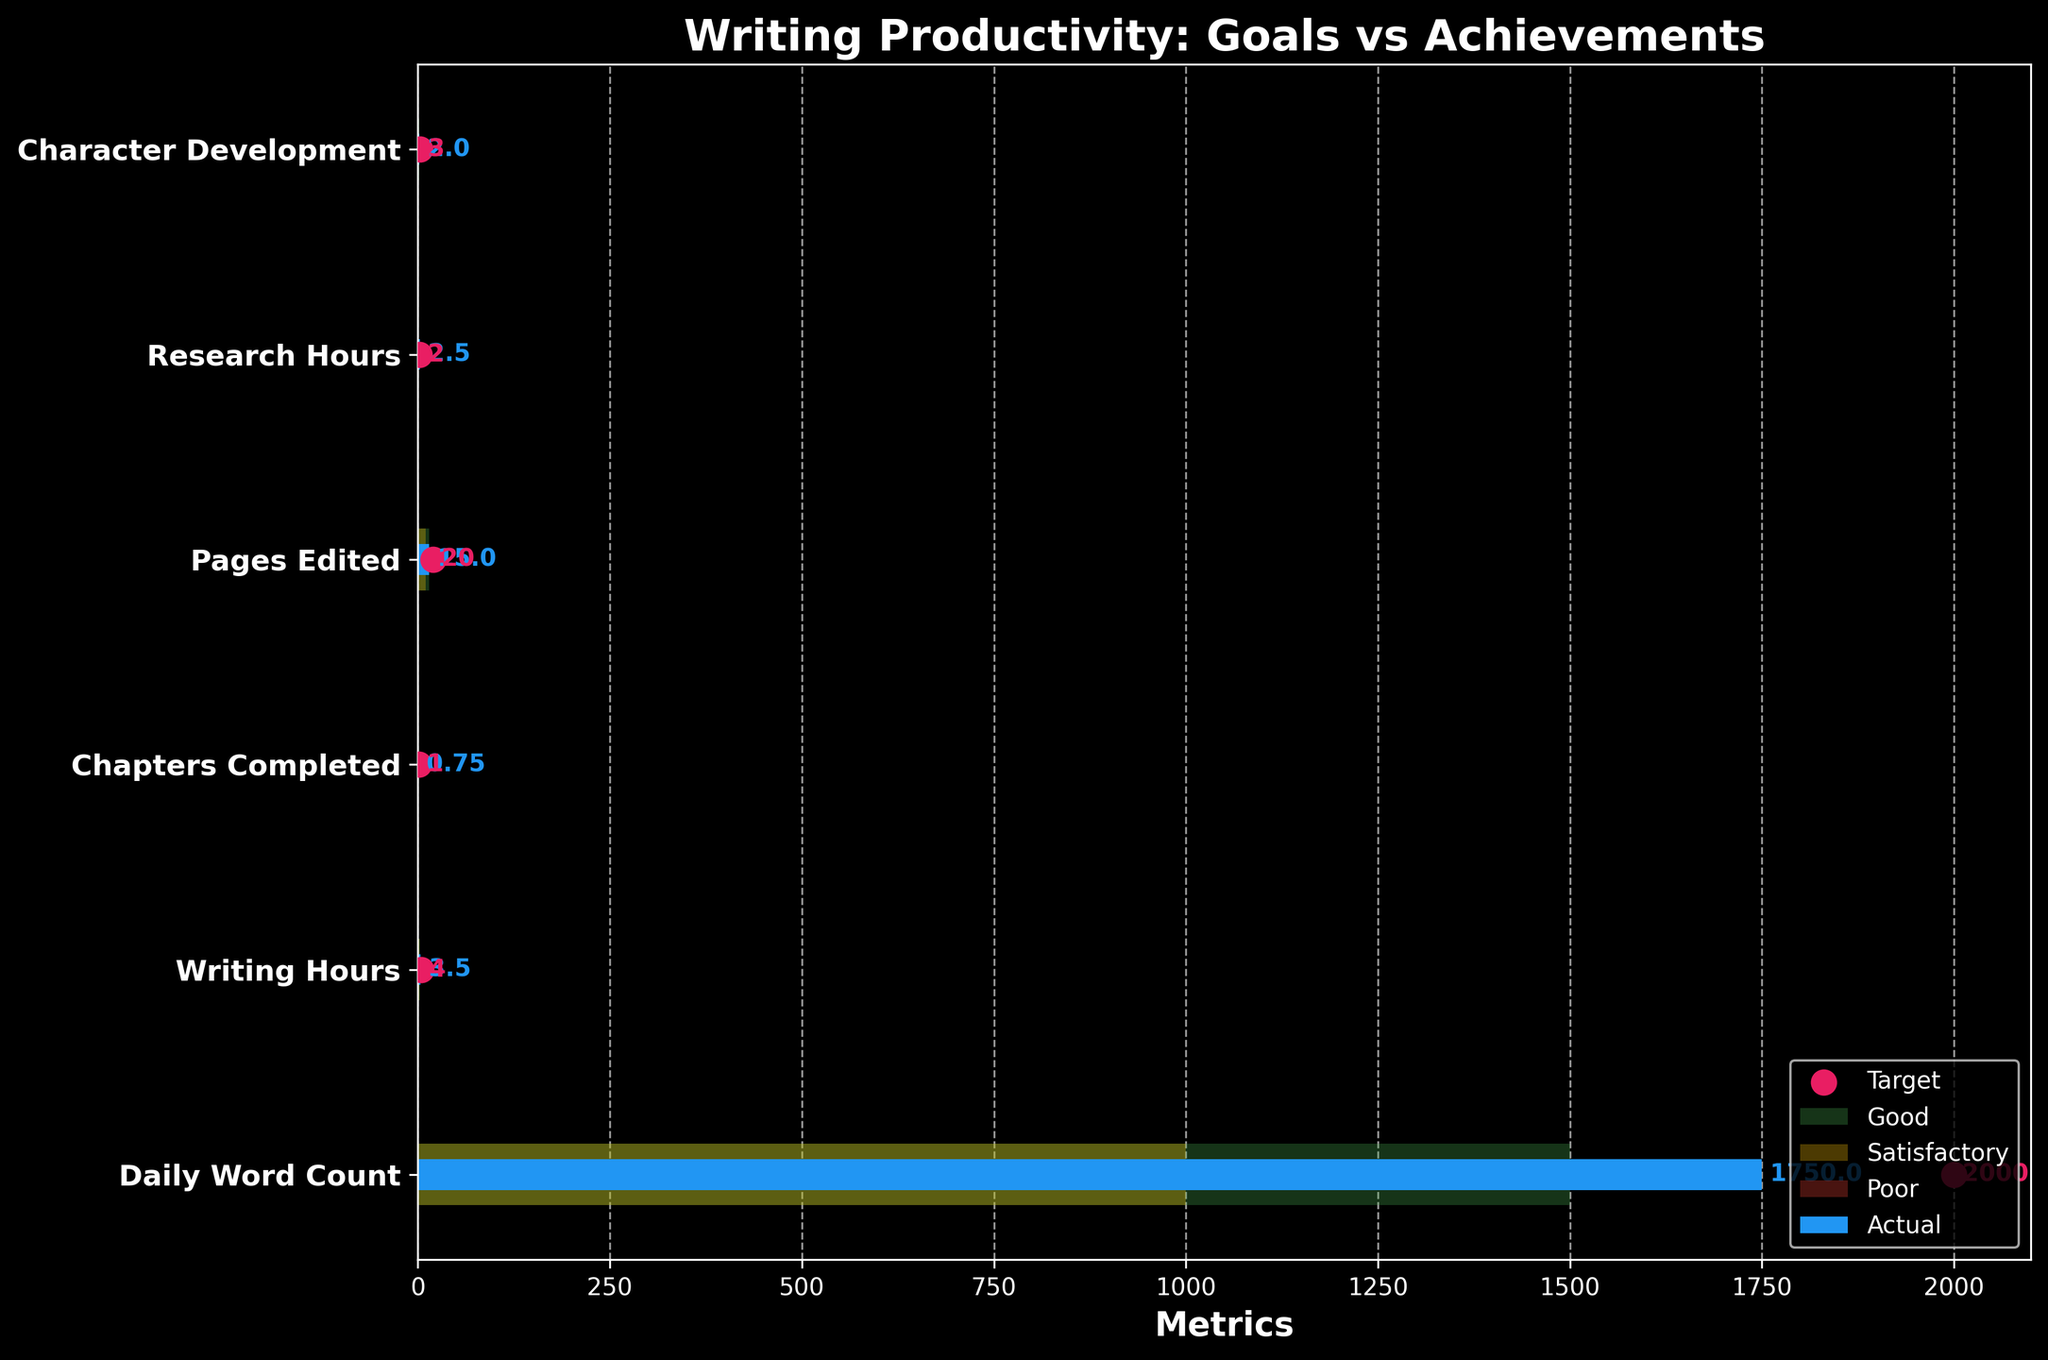How many categories are present in the chart? The chart has a bar for each category. Count the number of bars visible.
Answer: 6 What is the highest target value among all categories? Look at the target values (denoted as pink dots) for each category and identify the highest value.
Answer: Daily Word Count What is the difference between the actual and target values for the category "Research Hours"? Find the target and actual values for "Research Hours" and subtract the actual value from the target value to get the difference.
Answer: -0.5 Which category has the lowest actual value? Check the actual bar heights (blue bars) for all categories and identify the lowest one.
Answer: Chapters Completed Is the actual value for "Pages Edited" satisfactory or good? Compare the actual value (blue bar) for "Pages Edited" against the ranges defined for satisfactory and good in the chart.
Answer: Satisfactory Which categories achieved their target values? Compare the actual values (blue bars) with their corresponding target values (pink dots) to see which ones are equal or higher.
Answer: Research Hours What's the total of the actual values across all categories? Sum up the actual values of all categories: 1750 (Daily Word Count) + 3.5 (Writing Hours) + 0.75 (Chapters Completed) + 15 (Pages Edited) + 2.5 (Research Hours) + 2 (Character Development).
Answer: 1774.75 How many categories have their actual values in the "poor" range? Compare the actual values for each category against the "poor" range defined in the data to see how many fall into this range.
Answer: 0 Which has a larger gap between the actual and target values: "Character Development" or "Chapters Completed"? Calculate the gap for each (subtract actual value from target value) and compare them: Character Development (3 - 2 = 1) and Chapters Completed (1 - 0.75 = 0.25).
Answer: Character Development What is the overall average of the target values? Add all the target values and divide by the number of categories: (2000 + 4 + 1 + 20 + 2 + 3) / 6.
Answer: 338.3333 